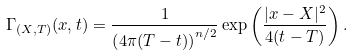Convert formula to latex. <formula><loc_0><loc_0><loc_500><loc_500>\Gamma _ { ( X , T ) } ( x , t ) = \frac { 1 } { \left ( 4 \pi ( T - t ) \right ) ^ { n / 2 } } \exp \left ( \frac { | x - X | ^ { 2 } } { 4 ( t - T ) } \right ) .</formula> 